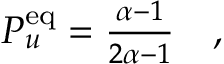Convert formula to latex. <formula><loc_0><loc_0><loc_500><loc_500>\begin{array} { r } { P _ { u } ^ { e q } = \frac { \alpha - 1 } { 2 \alpha - 1 } \quad , } \end{array}</formula> 